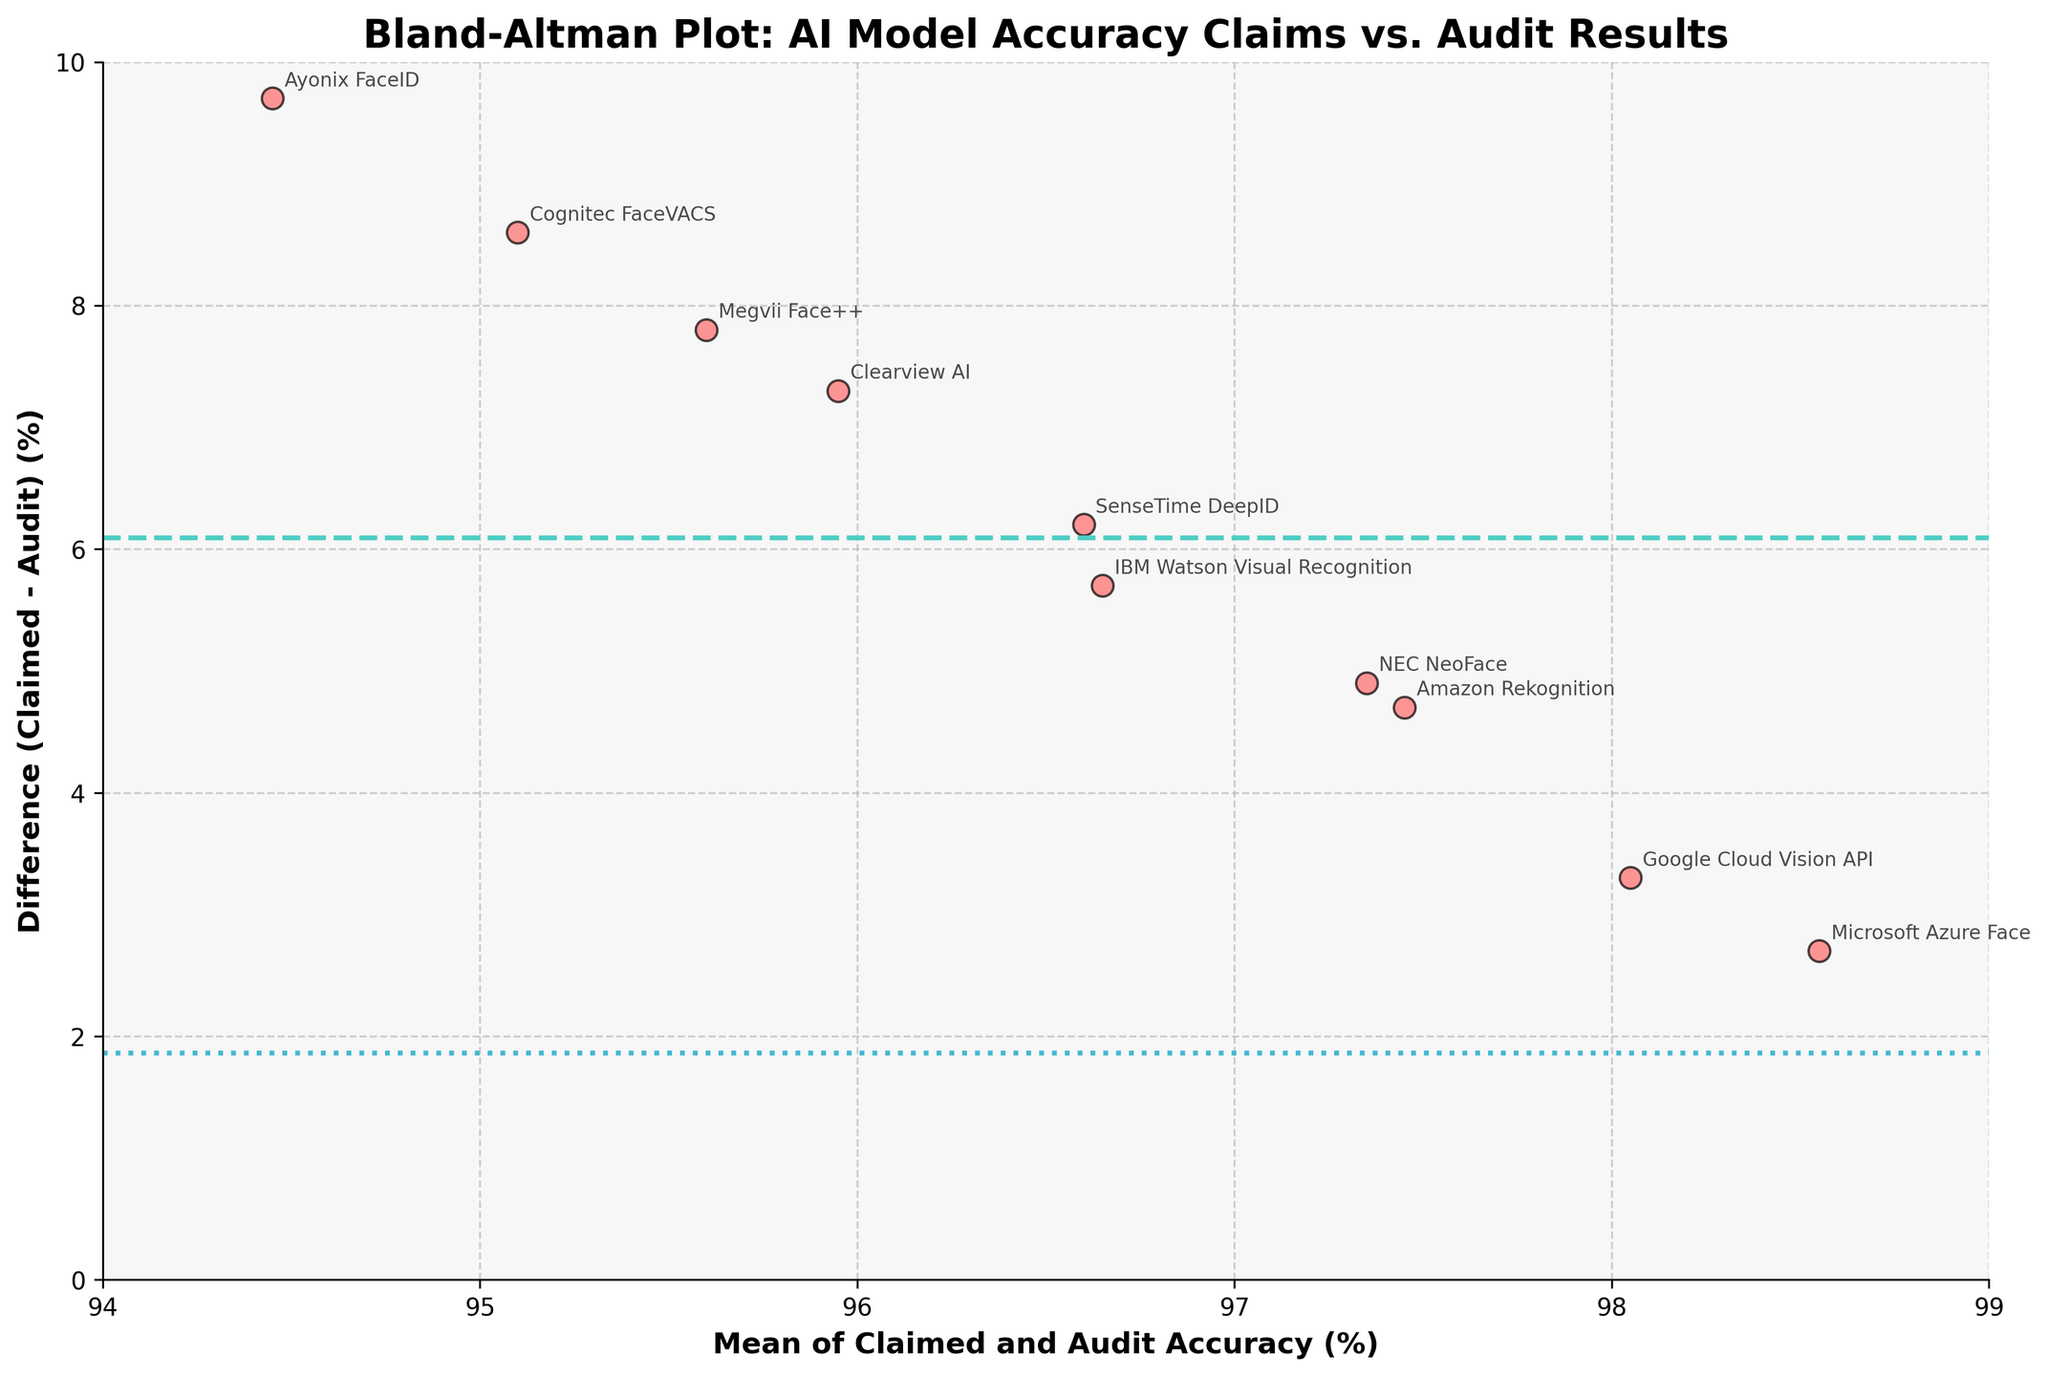What is the title of the plot? The title of the plot is typically located at the top of the figure, providing a brief description of what the plot represents. In this case, the title reads, "Bland-Altman Plot: AI Model Accuracy Claims vs. Audit Results."
Answer: Bland-Altman Plot: AI Model Accuracy Claims vs. Audit Results What is the mean difference line's color and style? The mean difference line in Bland-Altman plots often has a distinguishable appearance. Here, it is shown in a solid line style and colored in cyan.
Answer: Cyan, solid Which company has the largest difference between claimed and audit accuracy? To identify the company with the largest difference, we look for the highest scatter point on the y-axis, representing the difference between claimed and audit accuracy. In this case, Amazon Rekognition has the largest difference.
Answer: Amazon Rekognition Which company has the smallest difference between claimed and audit accuracy? By locating the scatter point closest to the x-axis (y=0), we find that Microsoft Azure Face has the smallest difference between claimed and audit accuracy.
Answer: Microsoft Azure Face What are the upper and lower limits of agreement, and what do they represent? The upper and lower limits of agreement are typically shown with dotted lines. They are calculated as the mean difference ± 1.96 times the standard deviation of the differences. These limits represent the range in which 95% of the differences are expected to fall.
Answer: Mean ± (1.96 * Std Dev) Which data point is furthest to the left on the x-axis, and what does this signify? The leftmost data point on the x-axis represents the smallest mean accuracy (average of claimed and audit accuracies). Ayonix FaceID is located furthest left, signifying it has the lowest average accuracy.
Answer: Ayonix FaceID How many companies have an average accuracy above 97%? Counting the number of scatter points to the right of the 97% mark on the x-axis, we find that four companies (Amazon Rekognition, Microsoft Azure Face, Google Cloud Vision API, and NEC NeoFace) have mean accuracy above 97%.
Answer: Four Which company has a claimed accuracy closest to the overall mean of the claimed accuracies? To identify this, one must compute the mean of all claimed accuracies and then compare each company's claimed accuracy to this mean. Given the data, Google Cloud Vision API's claimed accuracy (99.7) is closest to the mean of the claimed accuracies.
Answer: Google Cloud Vision API Are there any outliers in the audit accuracies based on the visual plot? Outliers would appear as points significantly distant from the others in the vertical direction on the plot. Looking at the data points, Ayonix FaceID and Cognitec FaceVACS have relatively lower audit accuracies (below 91), indicating potential outliers.
Answer: Ayonix FaceID, Cognitec FaceVACS Is there any company whose accuracy difference is zero? A difference of zero would mean that a point lies exactly on the x-axis. Examining the plot, no companies have a difference of zero; all points are above the x-axis.
Answer: No 